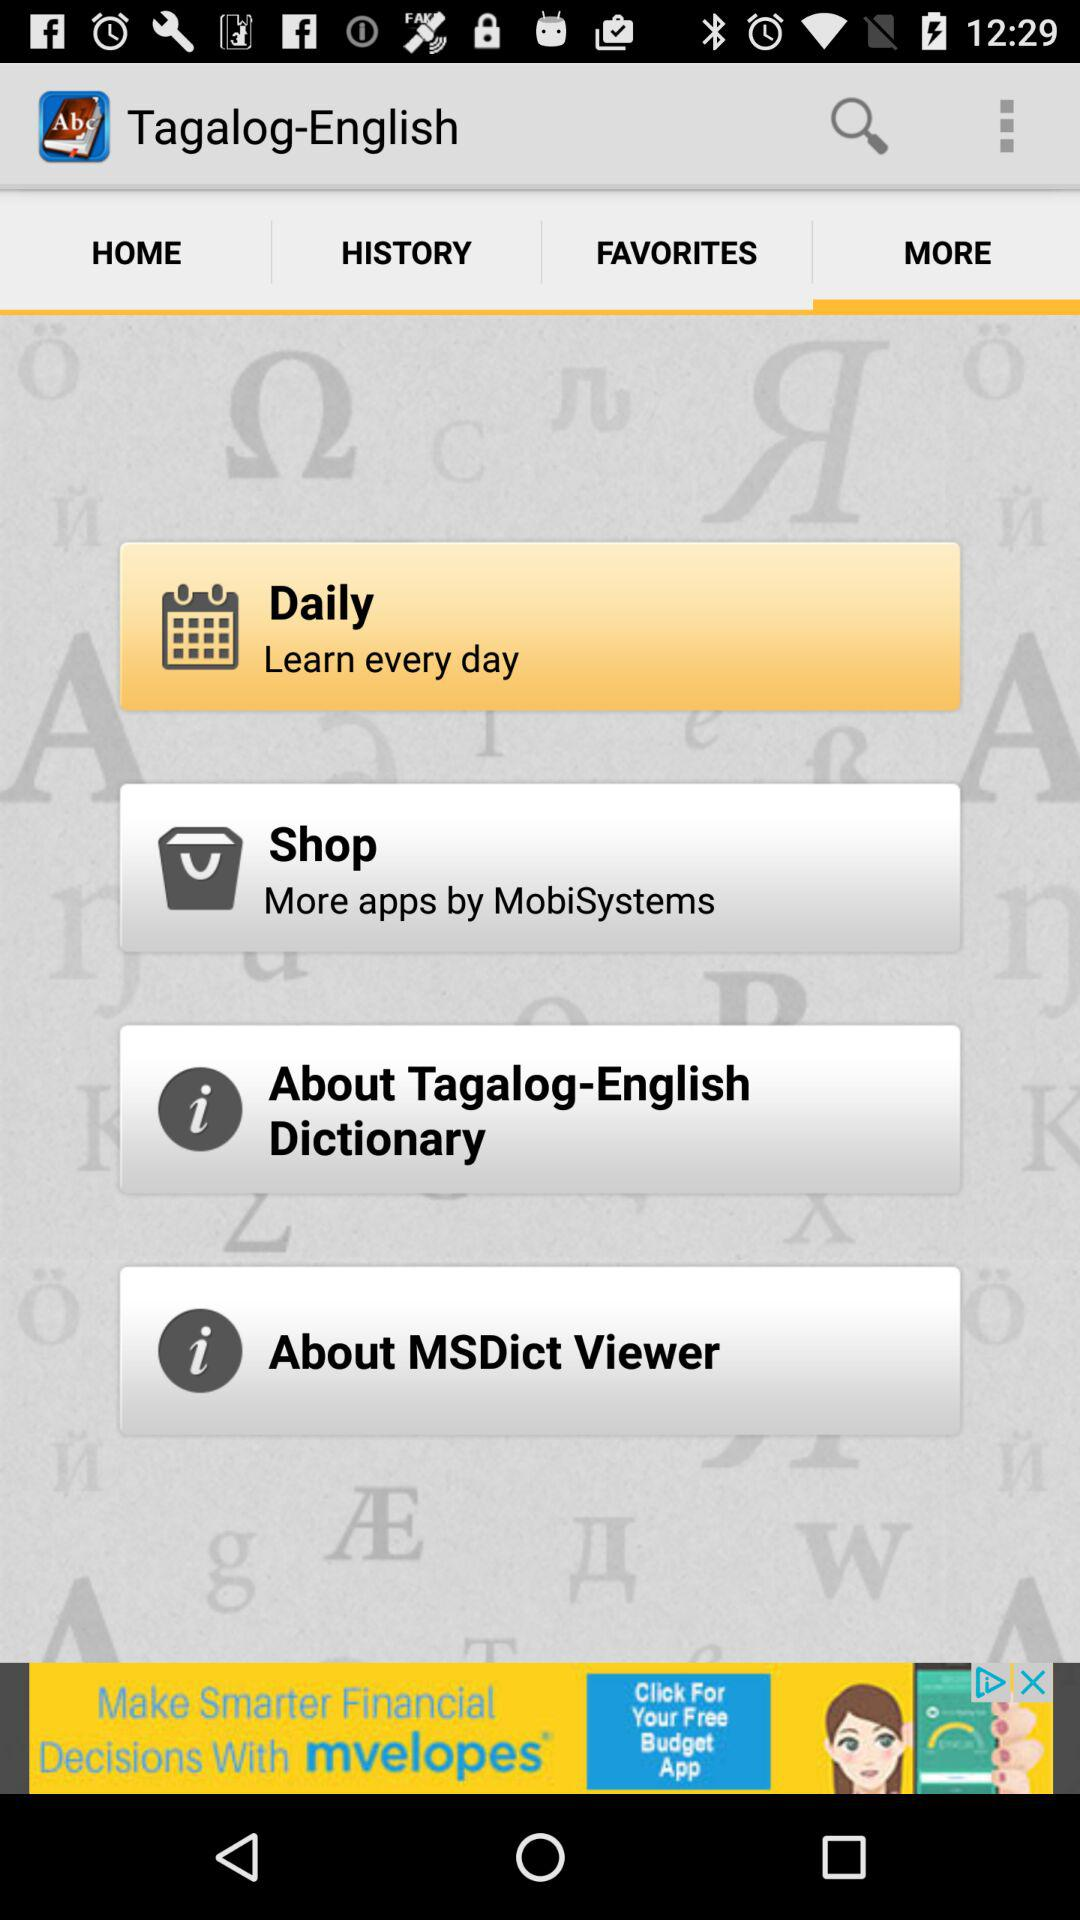Which tab has been selected? The selected tab is "MORE". 